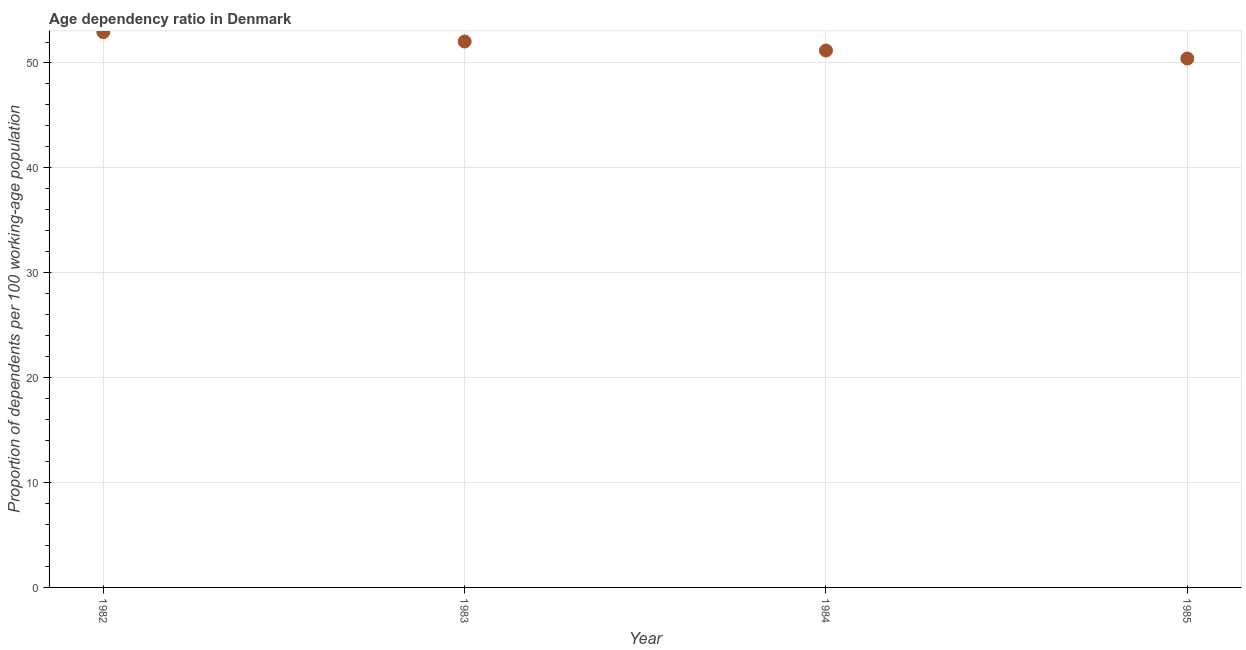What is the age dependency ratio in 1985?
Make the answer very short. 50.43. Across all years, what is the maximum age dependency ratio?
Provide a succinct answer. 52.94. Across all years, what is the minimum age dependency ratio?
Your response must be concise. 50.43. In which year was the age dependency ratio minimum?
Your answer should be compact. 1985. What is the sum of the age dependency ratio?
Give a very brief answer. 206.6. What is the difference between the age dependency ratio in 1983 and 1985?
Ensure brevity in your answer.  1.62. What is the average age dependency ratio per year?
Provide a succinct answer. 51.65. What is the median age dependency ratio?
Your answer should be compact. 51.62. Do a majority of the years between 1983 and 1984 (inclusive) have age dependency ratio greater than 18 ?
Provide a succinct answer. Yes. What is the ratio of the age dependency ratio in 1982 to that in 1984?
Give a very brief answer. 1.03. Is the difference between the age dependency ratio in 1982 and 1983 greater than the difference between any two years?
Provide a short and direct response. No. What is the difference between the highest and the second highest age dependency ratio?
Provide a short and direct response. 0.89. Is the sum of the age dependency ratio in 1983 and 1985 greater than the maximum age dependency ratio across all years?
Your answer should be very brief. Yes. What is the difference between the highest and the lowest age dependency ratio?
Your answer should be compact. 2.51. Does the age dependency ratio monotonically increase over the years?
Your answer should be very brief. No. How many dotlines are there?
Ensure brevity in your answer.  1. Are the values on the major ticks of Y-axis written in scientific E-notation?
Ensure brevity in your answer.  No. Does the graph contain any zero values?
Offer a very short reply. No. What is the title of the graph?
Keep it short and to the point. Age dependency ratio in Denmark. What is the label or title of the Y-axis?
Provide a short and direct response. Proportion of dependents per 100 working-age population. What is the Proportion of dependents per 100 working-age population in 1982?
Your answer should be compact. 52.94. What is the Proportion of dependents per 100 working-age population in 1983?
Your answer should be very brief. 52.05. What is the Proportion of dependents per 100 working-age population in 1984?
Your response must be concise. 51.19. What is the Proportion of dependents per 100 working-age population in 1985?
Keep it short and to the point. 50.43. What is the difference between the Proportion of dependents per 100 working-age population in 1982 and 1983?
Keep it short and to the point. 0.89. What is the difference between the Proportion of dependents per 100 working-age population in 1982 and 1984?
Provide a short and direct response. 1.75. What is the difference between the Proportion of dependents per 100 working-age population in 1982 and 1985?
Offer a very short reply. 2.51. What is the difference between the Proportion of dependents per 100 working-age population in 1983 and 1984?
Offer a terse response. 0.86. What is the difference between the Proportion of dependents per 100 working-age population in 1983 and 1985?
Provide a succinct answer. 1.62. What is the difference between the Proportion of dependents per 100 working-age population in 1984 and 1985?
Offer a terse response. 0.76. What is the ratio of the Proportion of dependents per 100 working-age population in 1982 to that in 1984?
Offer a very short reply. 1.03. What is the ratio of the Proportion of dependents per 100 working-age population in 1983 to that in 1985?
Provide a short and direct response. 1.03. 